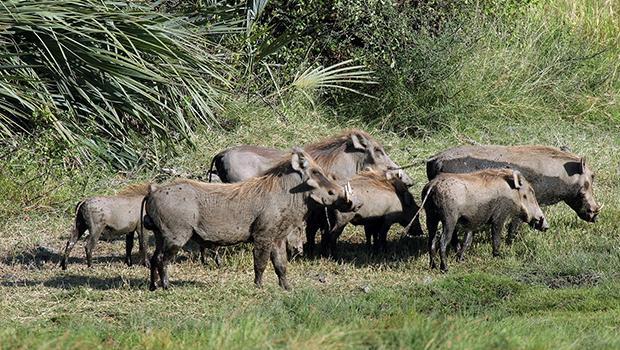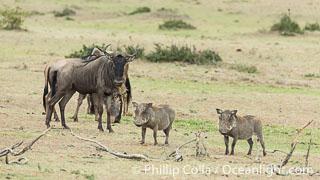The first image is the image on the left, the second image is the image on the right. Given the left and right images, does the statement "There is water in the image on the left." hold true? Answer yes or no. No. The first image is the image on the left, the second image is the image on the right. For the images displayed, is the sentence "In one of the images there is a group of warthogs standing near water." factually correct? Answer yes or no. No. 